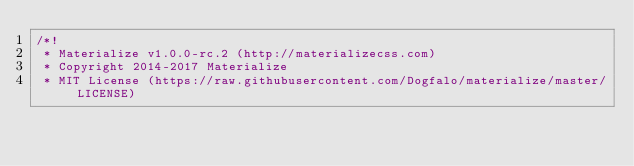<code> <loc_0><loc_0><loc_500><loc_500><_CSS_>/*!
 * Materialize v1.0.0-rc.2 (http://materializecss.com)
 * Copyright 2014-2017 Materialize
 * MIT License (https://raw.githubusercontent.com/Dogfalo/materialize/master/LICENSE)</code> 